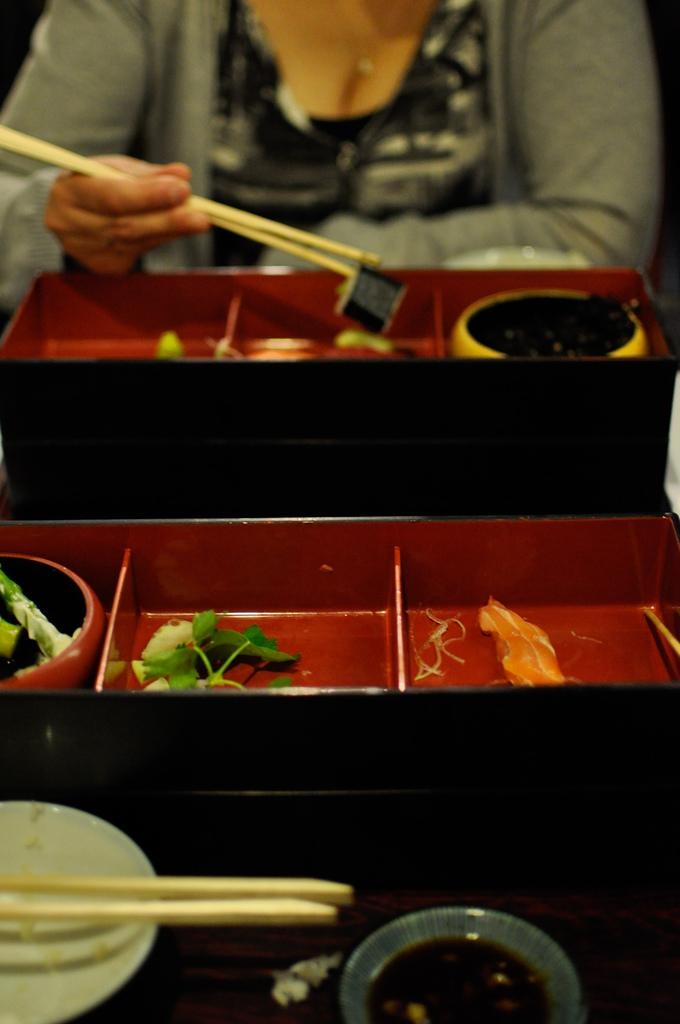What is on the table in the image? There is a plate, chopsticks, a bowl, containers, and food on the table. What utensils are present on the table? Chopsticks are present on the table. What is the woman in the image doing? The woman is sitting on a chair and holding chopsticks. What is the woman wearing in the image? The woman is wearing a jacket. What type of letter is the woman writing to the goose in the image? There is no letter or goose present in the image. 